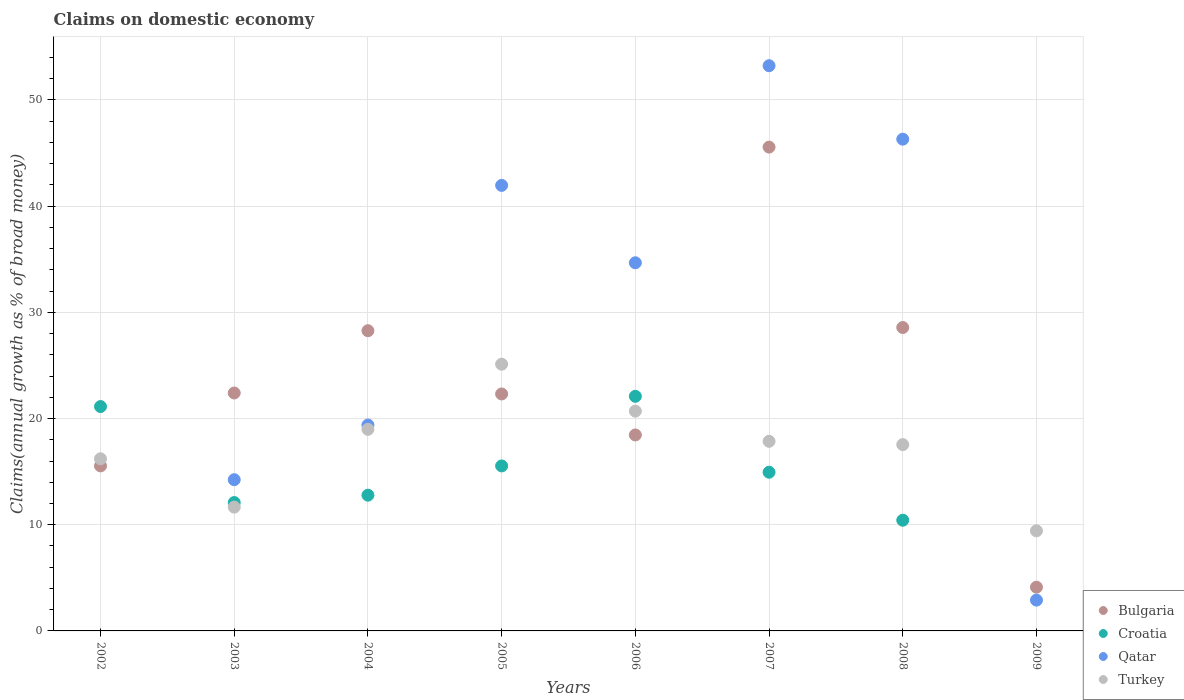How many different coloured dotlines are there?
Keep it short and to the point. 4. What is the percentage of broad money claimed on domestic economy in Bulgaria in 2005?
Your answer should be compact. 22.32. Across all years, what is the maximum percentage of broad money claimed on domestic economy in Bulgaria?
Give a very brief answer. 45.56. Across all years, what is the minimum percentage of broad money claimed on domestic economy in Bulgaria?
Make the answer very short. 4.12. In which year was the percentage of broad money claimed on domestic economy in Bulgaria maximum?
Ensure brevity in your answer.  2007. What is the total percentage of broad money claimed on domestic economy in Qatar in the graph?
Keep it short and to the point. 212.69. What is the difference between the percentage of broad money claimed on domestic economy in Turkey in 2003 and that in 2007?
Keep it short and to the point. -6.2. What is the difference between the percentage of broad money claimed on domestic economy in Croatia in 2005 and the percentage of broad money claimed on domestic economy in Turkey in 2007?
Ensure brevity in your answer.  -2.32. What is the average percentage of broad money claimed on domestic economy in Bulgaria per year?
Provide a succinct answer. 23.15. In the year 2009, what is the difference between the percentage of broad money claimed on domestic economy in Turkey and percentage of broad money claimed on domestic economy in Bulgaria?
Provide a short and direct response. 5.31. In how many years, is the percentage of broad money claimed on domestic economy in Turkey greater than 2 %?
Provide a succinct answer. 8. What is the ratio of the percentage of broad money claimed on domestic economy in Qatar in 2006 to that in 2007?
Keep it short and to the point. 0.65. Is the difference between the percentage of broad money claimed on domestic economy in Turkey in 2005 and 2006 greater than the difference between the percentage of broad money claimed on domestic economy in Bulgaria in 2005 and 2006?
Your response must be concise. Yes. What is the difference between the highest and the second highest percentage of broad money claimed on domestic economy in Qatar?
Ensure brevity in your answer.  6.92. What is the difference between the highest and the lowest percentage of broad money claimed on domestic economy in Turkey?
Keep it short and to the point. 15.69. Is it the case that in every year, the sum of the percentage of broad money claimed on domestic economy in Croatia and percentage of broad money claimed on domestic economy in Bulgaria  is greater than the percentage of broad money claimed on domestic economy in Qatar?
Give a very brief answer. No. Does the percentage of broad money claimed on domestic economy in Bulgaria monotonically increase over the years?
Offer a very short reply. No. How many dotlines are there?
Ensure brevity in your answer.  4. How many years are there in the graph?
Offer a terse response. 8. Does the graph contain any zero values?
Provide a succinct answer. Yes. Does the graph contain grids?
Make the answer very short. Yes. How are the legend labels stacked?
Offer a very short reply. Vertical. What is the title of the graph?
Provide a succinct answer. Claims on domestic economy. Does "Georgia" appear as one of the legend labels in the graph?
Your response must be concise. No. What is the label or title of the Y-axis?
Provide a short and direct response. Claims(annual growth as % of broad money). What is the Claims(annual growth as % of broad money) in Bulgaria in 2002?
Make the answer very short. 15.54. What is the Claims(annual growth as % of broad money) in Croatia in 2002?
Give a very brief answer. 21.13. What is the Claims(annual growth as % of broad money) in Qatar in 2002?
Keep it short and to the point. 0. What is the Claims(annual growth as % of broad money) in Turkey in 2002?
Keep it short and to the point. 16.21. What is the Claims(annual growth as % of broad money) in Bulgaria in 2003?
Offer a very short reply. 22.41. What is the Claims(annual growth as % of broad money) of Croatia in 2003?
Give a very brief answer. 12.09. What is the Claims(annual growth as % of broad money) of Qatar in 2003?
Provide a short and direct response. 14.24. What is the Claims(annual growth as % of broad money) in Turkey in 2003?
Your answer should be compact. 11.66. What is the Claims(annual growth as % of broad money) of Bulgaria in 2004?
Ensure brevity in your answer.  28.27. What is the Claims(annual growth as % of broad money) of Croatia in 2004?
Your response must be concise. 12.78. What is the Claims(annual growth as % of broad money) in Qatar in 2004?
Ensure brevity in your answer.  19.39. What is the Claims(annual growth as % of broad money) of Turkey in 2004?
Ensure brevity in your answer.  18.98. What is the Claims(annual growth as % of broad money) in Bulgaria in 2005?
Provide a succinct answer. 22.32. What is the Claims(annual growth as % of broad money) of Croatia in 2005?
Your answer should be compact. 15.54. What is the Claims(annual growth as % of broad money) in Qatar in 2005?
Provide a succinct answer. 41.96. What is the Claims(annual growth as % of broad money) of Turkey in 2005?
Your response must be concise. 25.12. What is the Claims(annual growth as % of broad money) of Bulgaria in 2006?
Your answer should be compact. 18.45. What is the Claims(annual growth as % of broad money) in Croatia in 2006?
Provide a succinct answer. 22.09. What is the Claims(annual growth as % of broad money) of Qatar in 2006?
Your answer should be very brief. 34.67. What is the Claims(annual growth as % of broad money) of Turkey in 2006?
Offer a very short reply. 20.7. What is the Claims(annual growth as % of broad money) in Bulgaria in 2007?
Ensure brevity in your answer.  45.56. What is the Claims(annual growth as % of broad money) of Croatia in 2007?
Give a very brief answer. 14.94. What is the Claims(annual growth as % of broad money) of Qatar in 2007?
Make the answer very short. 53.22. What is the Claims(annual growth as % of broad money) in Turkey in 2007?
Provide a short and direct response. 17.86. What is the Claims(annual growth as % of broad money) of Bulgaria in 2008?
Offer a terse response. 28.57. What is the Claims(annual growth as % of broad money) of Croatia in 2008?
Offer a very short reply. 10.42. What is the Claims(annual growth as % of broad money) of Qatar in 2008?
Give a very brief answer. 46.31. What is the Claims(annual growth as % of broad money) in Turkey in 2008?
Your answer should be very brief. 17.54. What is the Claims(annual growth as % of broad money) in Bulgaria in 2009?
Ensure brevity in your answer.  4.12. What is the Claims(annual growth as % of broad money) of Qatar in 2009?
Your answer should be compact. 2.9. What is the Claims(annual growth as % of broad money) of Turkey in 2009?
Give a very brief answer. 9.43. Across all years, what is the maximum Claims(annual growth as % of broad money) in Bulgaria?
Provide a succinct answer. 45.56. Across all years, what is the maximum Claims(annual growth as % of broad money) of Croatia?
Make the answer very short. 22.09. Across all years, what is the maximum Claims(annual growth as % of broad money) in Qatar?
Make the answer very short. 53.22. Across all years, what is the maximum Claims(annual growth as % of broad money) of Turkey?
Ensure brevity in your answer.  25.12. Across all years, what is the minimum Claims(annual growth as % of broad money) in Bulgaria?
Your response must be concise. 4.12. Across all years, what is the minimum Claims(annual growth as % of broad money) of Croatia?
Keep it short and to the point. 0. Across all years, what is the minimum Claims(annual growth as % of broad money) in Turkey?
Provide a succinct answer. 9.43. What is the total Claims(annual growth as % of broad money) of Bulgaria in the graph?
Offer a terse response. 185.24. What is the total Claims(annual growth as % of broad money) in Croatia in the graph?
Your answer should be very brief. 109. What is the total Claims(annual growth as % of broad money) of Qatar in the graph?
Keep it short and to the point. 212.69. What is the total Claims(annual growth as % of broad money) of Turkey in the graph?
Your response must be concise. 137.49. What is the difference between the Claims(annual growth as % of broad money) of Bulgaria in 2002 and that in 2003?
Provide a succinct answer. -6.86. What is the difference between the Claims(annual growth as % of broad money) in Croatia in 2002 and that in 2003?
Offer a very short reply. 9.04. What is the difference between the Claims(annual growth as % of broad money) of Turkey in 2002 and that in 2003?
Offer a terse response. 4.55. What is the difference between the Claims(annual growth as % of broad money) of Bulgaria in 2002 and that in 2004?
Your response must be concise. -12.73. What is the difference between the Claims(annual growth as % of broad money) in Croatia in 2002 and that in 2004?
Ensure brevity in your answer.  8.35. What is the difference between the Claims(annual growth as % of broad money) of Turkey in 2002 and that in 2004?
Offer a terse response. -2.77. What is the difference between the Claims(annual growth as % of broad money) in Bulgaria in 2002 and that in 2005?
Provide a short and direct response. -6.77. What is the difference between the Claims(annual growth as % of broad money) in Croatia in 2002 and that in 2005?
Keep it short and to the point. 5.59. What is the difference between the Claims(annual growth as % of broad money) of Turkey in 2002 and that in 2005?
Give a very brief answer. -8.91. What is the difference between the Claims(annual growth as % of broad money) of Bulgaria in 2002 and that in 2006?
Keep it short and to the point. -2.91. What is the difference between the Claims(annual growth as % of broad money) of Croatia in 2002 and that in 2006?
Offer a terse response. -0.96. What is the difference between the Claims(annual growth as % of broad money) in Turkey in 2002 and that in 2006?
Provide a succinct answer. -4.49. What is the difference between the Claims(annual growth as % of broad money) in Bulgaria in 2002 and that in 2007?
Give a very brief answer. -30.02. What is the difference between the Claims(annual growth as % of broad money) of Croatia in 2002 and that in 2007?
Offer a very short reply. 6.18. What is the difference between the Claims(annual growth as % of broad money) in Turkey in 2002 and that in 2007?
Your answer should be very brief. -1.65. What is the difference between the Claims(annual growth as % of broad money) in Bulgaria in 2002 and that in 2008?
Your answer should be very brief. -13.03. What is the difference between the Claims(annual growth as % of broad money) in Croatia in 2002 and that in 2008?
Offer a very short reply. 10.7. What is the difference between the Claims(annual growth as % of broad money) in Turkey in 2002 and that in 2008?
Your answer should be very brief. -1.34. What is the difference between the Claims(annual growth as % of broad money) of Bulgaria in 2002 and that in 2009?
Provide a short and direct response. 11.42. What is the difference between the Claims(annual growth as % of broad money) in Turkey in 2002 and that in 2009?
Ensure brevity in your answer.  6.78. What is the difference between the Claims(annual growth as % of broad money) in Bulgaria in 2003 and that in 2004?
Offer a very short reply. -5.87. What is the difference between the Claims(annual growth as % of broad money) of Croatia in 2003 and that in 2004?
Offer a terse response. -0.7. What is the difference between the Claims(annual growth as % of broad money) in Qatar in 2003 and that in 2004?
Make the answer very short. -5.15. What is the difference between the Claims(annual growth as % of broad money) in Turkey in 2003 and that in 2004?
Give a very brief answer. -7.32. What is the difference between the Claims(annual growth as % of broad money) of Bulgaria in 2003 and that in 2005?
Provide a short and direct response. 0.09. What is the difference between the Claims(annual growth as % of broad money) in Croatia in 2003 and that in 2005?
Ensure brevity in your answer.  -3.45. What is the difference between the Claims(annual growth as % of broad money) of Qatar in 2003 and that in 2005?
Offer a very short reply. -27.72. What is the difference between the Claims(annual growth as % of broad money) in Turkey in 2003 and that in 2005?
Make the answer very short. -13.46. What is the difference between the Claims(annual growth as % of broad money) in Bulgaria in 2003 and that in 2006?
Provide a succinct answer. 3.95. What is the difference between the Claims(annual growth as % of broad money) of Croatia in 2003 and that in 2006?
Ensure brevity in your answer.  -10.01. What is the difference between the Claims(annual growth as % of broad money) in Qatar in 2003 and that in 2006?
Make the answer very short. -20.43. What is the difference between the Claims(annual growth as % of broad money) of Turkey in 2003 and that in 2006?
Offer a very short reply. -9.04. What is the difference between the Claims(annual growth as % of broad money) in Bulgaria in 2003 and that in 2007?
Your answer should be compact. -23.15. What is the difference between the Claims(annual growth as % of broad money) in Croatia in 2003 and that in 2007?
Your response must be concise. -2.86. What is the difference between the Claims(annual growth as % of broad money) of Qatar in 2003 and that in 2007?
Your response must be concise. -38.98. What is the difference between the Claims(annual growth as % of broad money) of Turkey in 2003 and that in 2007?
Provide a short and direct response. -6.2. What is the difference between the Claims(annual growth as % of broad money) in Bulgaria in 2003 and that in 2008?
Offer a terse response. -6.16. What is the difference between the Claims(annual growth as % of broad money) of Croatia in 2003 and that in 2008?
Your response must be concise. 1.66. What is the difference between the Claims(annual growth as % of broad money) in Qatar in 2003 and that in 2008?
Provide a succinct answer. -32.07. What is the difference between the Claims(annual growth as % of broad money) of Turkey in 2003 and that in 2008?
Offer a terse response. -5.88. What is the difference between the Claims(annual growth as % of broad money) of Bulgaria in 2003 and that in 2009?
Ensure brevity in your answer.  18.29. What is the difference between the Claims(annual growth as % of broad money) in Qatar in 2003 and that in 2009?
Your answer should be very brief. 11.34. What is the difference between the Claims(annual growth as % of broad money) in Turkey in 2003 and that in 2009?
Offer a terse response. 2.23. What is the difference between the Claims(annual growth as % of broad money) in Bulgaria in 2004 and that in 2005?
Your answer should be compact. 5.96. What is the difference between the Claims(annual growth as % of broad money) in Croatia in 2004 and that in 2005?
Provide a short and direct response. -2.75. What is the difference between the Claims(annual growth as % of broad money) in Qatar in 2004 and that in 2005?
Offer a very short reply. -22.57. What is the difference between the Claims(annual growth as % of broad money) in Turkey in 2004 and that in 2005?
Your response must be concise. -6.14. What is the difference between the Claims(annual growth as % of broad money) of Bulgaria in 2004 and that in 2006?
Offer a very short reply. 9.82. What is the difference between the Claims(annual growth as % of broad money) of Croatia in 2004 and that in 2006?
Ensure brevity in your answer.  -9.31. What is the difference between the Claims(annual growth as % of broad money) in Qatar in 2004 and that in 2006?
Your answer should be compact. -15.28. What is the difference between the Claims(annual growth as % of broad money) of Turkey in 2004 and that in 2006?
Your answer should be very brief. -1.71. What is the difference between the Claims(annual growth as % of broad money) of Bulgaria in 2004 and that in 2007?
Provide a short and direct response. -17.29. What is the difference between the Claims(annual growth as % of broad money) in Croatia in 2004 and that in 2007?
Your answer should be very brief. -2.16. What is the difference between the Claims(annual growth as % of broad money) of Qatar in 2004 and that in 2007?
Your response must be concise. -33.84. What is the difference between the Claims(annual growth as % of broad money) in Turkey in 2004 and that in 2007?
Ensure brevity in your answer.  1.13. What is the difference between the Claims(annual growth as % of broad money) in Bulgaria in 2004 and that in 2008?
Make the answer very short. -0.3. What is the difference between the Claims(annual growth as % of broad money) in Croatia in 2004 and that in 2008?
Provide a short and direct response. 2.36. What is the difference between the Claims(annual growth as % of broad money) in Qatar in 2004 and that in 2008?
Make the answer very short. -26.92. What is the difference between the Claims(annual growth as % of broad money) of Turkey in 2004 and that in 2008?
Your answer should be very brief. 1.44. What is the difference between the Claims(annual growth as % of broad money) of Bulgaria in 2004 and that in 2009?
Give a very brief answer. 24.15. What is the difference between the Claims(annual growth as % of broad money) of Qatar in 2004 and that in 2009?
Provide a succinct answer. 16.49. What is the difference between the Claims(annual growth as % of broad money) of Turkey in 2004 and that in 2009?
Provide a short and direct response. 9.56. What is the difference between the Claims(annual growth as % of broad money) in Bulgaria in 2005 and that in 2006?
Your answer should be compact. 3.86. What is the difference between the Claims(annual growth as % of broad money) of Croatia in 2005 and that in 2006?
Ensure brevity in your answer.  -6.55. What is the difference between the Claims(annual growth as % of broad money) of Qatar in 2005 and that in 2006?
Give a very brief answer. 7.29. What is the difference between the Claims(annual growth as % of broad money) in Turkey in 2005 and that in 2006?
Your answer should be compact. 4.42. What is the difference between the Claims(annual growth as % of broad money) of Bulgaria in 2005 and that in 2007?
Provide a short and direct response. -23.24. What is the difference between the Claims(annual growth as % of broad money) of Croatia in 2005 and that in 2007?
Give a very brief answer. 0.59. What is the difference between the Claims(annual growth as % of broad money) in Qatar in 2005 and that in 2007?
Keep it short and to the point. -11.27. What is the difference between the Claims(annual growth as % of broad money) in Turkey in 2005 and that in 2007?
Provide a short and direct response. 7.26. What is the difference between the Claims(annual growth as % of broad money) of Bulgaria in 2005 and that in 2008?
Offer a very short reply. -6.26. What is the difference between the Claims(annual growth as % of broad money) in Croatia in 2005 and that in 2008?
Offer a terse response. 5.11. What is the difference between the Claims(annual growth as % of broad money) in Qatar in 2005 and that in 2008?
Offer a very short reply. -4.35. What is the difference between the Claims(annual growth as % of broad money) in Turkey in 2005 and that in 2008?
Provide a succinct answer. 7.57. What is the difference between the Claims(annual growth as % of broad money) of Bulgaria in 2005 and that in 2009?
Ensure brevity in your answer.  18.2. What is the difference between the Claims(annual growth as % of broad money) in Qatar in 2005 and that in 2009?
Keep it short and to the point. 39.06. What is the difference between the Claims(annual growth as % of broad money) of Turkey in 2005 and that in 2009?
Your answer should be very brief. 15.69. What is the difference between the Claims(annual growth as % of broad money) of Bulgaria in 2006 and that in 2007?
Offer a very short reply. -27.11. What is the difference between the Claims(annual growth as % of broad money) of Croatia in 2006 and that in 2007?
Your answer should be very brief. 7.15. What is the difference between the Claims(annual growth as % of broad money) in Qatar in 2006 and that in 2007?
Ensure brevity in your answer.  -18.56. What is the difference between the Claims(annual growth as % of broad money) in Turkey in 2006 and that in 2007?
Offer a terse response. 2.84. What is the difference between the Claims(annual growth as % of broad money) of Bulgaria in 2006 and that in 2008?
Offer a terse response. -10.12. What is the difference between the Claims(annual growth as % of broad money) in Croatia in 2006 and that in 2008?
Your answer should be very brief. 11.67. What is the difference between the Claims(annual growth as % of broad money) in Qatar in 2006 and that in 2008?
Your answer should be compact. -11.64. What is the difference between the Claims(annual growth as % of broad money) of Turkey in 2006 and that in 2008?
Your answer should be compact. 3.15. What is the difference between the Claims(annual growth as % of broad money) of Bulgaria in 2006 and that in 2009?
Offer a very short reply. 14.33. What is the difference between the Claims(annual growth as % of broad money) of Qatar in 2006 and that in 2009?
Offer a very short reply. 31.77. What is the difference between the Claims(annual growth as % of broad money) in Turkey in 2006 and that in 2009?
Offer a very short reply. 11.27. What is the difference between the Claims(annual growth as % of broad money) in Bulgaria in 2007 and that in 2008?
Your response must be concise. 16.99. What is the difference between the Claims(annual growth as % of broad money) of Croatia in 2007 and that in 2008?
Provide a succinct answer. 4.52. What is the difference between the Claims(annual growth as % of broad money) in Qatar in 2007 and that in 2008?
Offer a terse response. 6.92. What is the difference between the Claims(annual growth as % of broad money) in Turkey in 2007 and that in 2008?
Keep it short and to the point. 0.31. What is the difference between the Claims(annual growth as % of broad money) in Bulgaria in 2007 and that in 2009?
Provide a succinct answer. 41.44. What is the difference between the Claims(annual growth as % of broad money) in Qatar in 2007 and that in 2009?
Ensure brevity in your answer.  50.32. What is the difference between the Claims(annual growth as % of broad money) of Turkey in 2007 and that in 2009?
Your response must be concise. 8.43. What is the difference between the Claims(annual growth as % of broad money) of Bulgaria in 2008 and that in 2009?
Ensure brevity in your answer.  24.45. What is the difference between the Claims(annual growth as % of broad money) in Qatar in 2008 and that in 2009?
Give a very brief answer. 43.41. What is the difference between the Claims(annual growth as % of broad money) in Turkey in 2008 and that in 2009?
Your answer should be compact. 8.12. What is the difference between the Claims(annual growth as % of broad money) in Bulgaria in 2002 and the Claims(annual growth as % of broad money) in Croatia in 2003?
Provide a short and direct response. 3.45. What is the difference between the Claims(annual growth as % of broad money) in Bulgaria in 2002 and the Claims(annual growth as % of broad money) in Qatar in 2003?
Your answer should be very brief. 1.3. What is the difference between the Claims(annual growth as % of broad money) of Bulgaria in 2002 and the Claims(annual growth as % of broad money) of Turkey in 2003?
Your answer should be very brief. 3.88. What is the difference between the Claims(annual growth as % of broad money) in Croatia in 2002 and the Claims(annual growth as % of broad money) in Qatar in 2003?
Provide a short and direct response. 6.89. What is the difference between the Claims(annual growth as % of broad money) of Croatia in 2002 and the Claims(annual growth as % of broad money) of Turkey in 2003?
Offer a terse response. 9.47. What is the difference between the Claims(annual growth as % of broad money) of Bulgaria in 2002 and the Claims(annual growth as % of broad money) of Croatia in 2004?
Ensure brevity in your answer.  2.76. What is the difference between the Claims(annual growth as % of broad money) of Bulgaria in 2002 and the Claims(annual growth as % of broad money) of Qatar in 2004?
Your answer should be compact. -3.85. What is the difference between the Claims(annual growth as % of broad money) in Bulgaria in 2002 and the Claims(annual growth as % of broad money) in Turkey in 2004?
Provide a succinct answer. -3.44. What is the difference between the Claims(annual growth as % of broad money) in Croatia in 2002 and the Claims(annual growth as % of broad money) in Qatar in 2004?
Provide a succinct answer. 1.74. What is the difference between the Claims(annual growth as % of broad money) of Croatia in 2002 and the Claims(annual growth as % of broad money) of Turkey in 2004?
Keep it short and to the point. 2.15. What is the difference between the Claims(annual growth as % of broad money) of Bulgaria in 2002 and the Claims(annual growth as % of broad money) of Croatia in 2005?
Your answer should be compact. 0. What is the difference between the Claims(annual growth as % of broad money) in Bulgaria in 2002 and the Claims(annual growth as % of broad money) in Qatar in 2005?
Ensure brevity in your answer.  -26.41. What is the difference between the Claims(annual growth as % of broad money) in Bulgaria in 2002 and the Claims(annual growth as % of broad money) in Turkey in 2005?
Your answer should be compact. -9.58. What is the difference between the Claims(annual growth as % of broad money) of Croatia in 2002 and the Claims(annual growth as % of broad money) of Qatar in 2005?
Provide a succinct answer. -20.83. What is the difference between the Claims(annual growth as % of broad money) of Croatia in 2002 and the Claims(annual growth as % of broad money) of Turkey in 2005?
Provide a succinct answer. -3.99. What is the difference between the Claims(annual growth as % of broad money) in Bulgaria in 2002 and the Claims(annual growth as % of broad money) in Croatia in 2006?
Your answer should be compact. -6.55. What is the difference between the Claims(annual growth as % of broad money) of Bulgaria in 2002 and the Claims(annual growth as % of broad money) of Qatar in 2006?
Your answer should be compact. -19.13. What is the difference between the Claims(annual growth as % of broad money) in Bulgaria in 2002 and the Claims(annual growth as % of broad money) in Turkey in 2006?
Make the answer very short. -5.15. What is the difference between the Claims(annual growth as % of broad money) of Croatia in 2002 and the Claims(annual growth as % of broad money) of Qatar in 2006?
Your answer should be very brief. -13.54. What is the difference between the Claims(annual growth as % of broad money) in Croatia in 2002 and the Claims(annual growth as % of broad money) in Turkey in 2006?
Offer a terse response. 0.43. What is the difference between the Claims(annual growth as % of broad money) in Bulgaria in 2002 and the Claims(annual growth as % of broad money) in Croatia in 2007?
Your answer should be very brief. 0.6. What is the difference between the Claims(annual growth as % of broad money) in Bulgaria in 2002 and the Claims(annual growth as % of broad money) in Qatar in 2007?
Keep it short and to the point. -37.68. What is the difference between the Claims(annual growth as % of broad money) in Bulgaria in 2002 and the Claims(annual growth as % of broad money) in Turkey in 2007?
Make the answer very short. -2.31. What is the difference between the Claims(annual growth as % of broad money) of Croatia in 2002 and the Claims(annual growth as % of broad money) of Qatar in 2007?
Make the answer very short. -32.1. What is the difference between the Claims(annual growth as % of broad money) of Croatia in 2002 and the Claims(annual growth as % of broad money) of Turkey in 2007?
Make the answer very short. 3.27. What is the difference between the Claims(annual growth as % of broad money) in Bulgaria in 2002 and the Claims(annual growth as % of broad money) in Croatia in 2008?
Make the answer very short. 5.12. What is the difference between the Claims(annual growth as % of broad money) in Bulgaria in 2002 and the Claims(annual growth as % of broad money) in Qatar in 2008?
Give a very brief answer. -30.77. What is the difference between the Claims(annual growth as % of broad money) of Bulgaria in 2002 and the Claims(annual growth as % of broad money) of Turkey in 2008?
Keep it short and to the point. -2. What is the difference between the Claims(annual growth as % of broad money) of Croatia in 2002 and the Claims(annual growth as % of broad money) of Qatar in 2008?
Offer a terse response. -25.18. What is the difference between the Claims(annual growth as % of broad money) in Croatia in 2002 and the Claims(annual growth as % of broad money) in Turkey in 2008?
Give a very brief answer. 3.58. What is the difference between the Claims(annual growth as % of broad money) of Bulgaria in 2002 and the Claims(annual growth as % of broad money) of Qatar in 2009?
Offer a very short reply. 12.64. What is the difference between the Claims(annual growth as % of broad money) of Bulgaria in 2002 and the Claims(annual growth as % of broad money) of Turkey in 2009?
Offer a terse response. 6.11. What is the difference between the Claims(annual growth as % of broad money) in Croatia in 2002 and the Claims(annual growth as % of broad money) in Qatar in 2009?
Ensure brevity in your answer.  18.23. What is the difference between the Claims(annual growth as % of broad money) of Croatia in 2002 and the Claims(annual growth as % of broad money) of Turkey in 2009?
Keep it short and to the point. 11.7. What is the difference between the Claims(annual growth as % of broad money) in Bulgaria in 2003 and the Claims(annual growth as % of broad money) in Croatia in 2004?
Provide a short and direct response. 9.62. What is the difference between the Claims(annual growth as % of broad money) in Bulgaria in 2003 and the Claims(annual growth as % of broad money) in Qatar in 2004?
Give a very brief answer. 3.02. What is the difference between the Claims(annual growth as % of broad money) of Bulgaria in 2003 and the Claims(annual growth as % of broad money) of Turkey in 2004?
Give a very brief answer. 3.42. What is the difference between the Claims(annual growth as % of broad money) in Croatia in 2003 and the Claims(annual growth as % of broad money) in Qatar in 2004?
Your response must be concise. -7.3. What is the difference between the Claims(annual growth as % of broad money) of Croatia in 2003 and the Claims(annual growth as % of broad money) of Turkey in 2004?
Offer a very short reply. -6.9. What is the difference between the Claims(annual growth as % of broad money) of Qatar in 2003 and the Claims(annual growth as % of broad money) of Turkey in 2004?
Provide a succinct answer. -4.74. What is the difference between the Claims(annual growth as % of broad money) of Bulgaria in 2003 and the Claims(annual growth as % of broad money) of Croatia in 2005?
Your answer should be very brief. 6.87. What is the difference between the Claims(annual growth as % of broad money) in Bulgaria in 2003 and the Claims(annual growth as % of broad money) in Qatar in 2005?
Ensure brevity in your answer.  -19.55. What is the difference between the Claims(annual growth as % of broad money) of Bulgaria in 2003 and the Claims(annual growth as % of broad money) of Turkey in 2005?
Your response must be concise. -2.71. What is the difference between the Claims(annual growth as % of broad money) in Croatia in 2003 and the Claims(annual growth as % of broad money) in Qatar in 2005?
Your answer should be compact. -29.87. What is the difference between the Claims(annual growth as % of broad money) of Croatia in 2003 and the Claims(annual growth as % of broad money) of Turkey in 2005?
Your answer should be compact. -13.03. What is the difference between the Claims(annual growth as % of broad money) of Qatar in 2003 and the Claims(annual growth as % of broad money) of Turkey in 2005?
Keep it short and to the point. -10.88. What is the difference between the Claims(annual growth as % of broad money) in Bulgaria in 2003 and the Claims(annual growth as % of broad money) in Croatia in 2006?
Provide a short and direct response. 0.31. What is the difference between the Claims(annual growth as % of broad money) in Bulgaria in 2003 and the Claims(annual growth as % of broad money) in Qatar in 2006?
Provide a succinct answer. -12.26. What is the difference between the Claims(annual growth as % of broad money) in Bulgaria in 2003 and the Claims(annual growth as % of broad money) in Turkey in 2006?
Make the answer very short. 1.71. What is the difference between the Claims(annual growth as % of broad money) of Croatia in 2003 and the Claims(annual growth as % of broad money) of Qatar in 2006?
Give a very brief answer. -22.58. What is the difference between the Claims(annual growth as % of broad money) in Croatia in 2003 and the Claims(annual growth as % of broad money) in Turkey in 2006?
Your answer should be compact. -8.61. What is the difference between the Claims(annual growth as % of broad money) in Qatar in 2003 and the Claims(annual growth as % of broad money) in Turkey in 2006?
Make the answer very short. -6.46. What is the difference between the Claims(annual growth as % of broad money) in Bulgaria in 2003 and the Claims(annual growth as % of broad money) in Croatia in 2007?
Your response must be concise. 7.46. What is the difference between the Claims(annual growth as % of broad money) in Bulgaria in 2003 and the Claims(annual growth as % of broad money) in Qatar in 2007?
Your response must be concise. -30.82. What is the difference between the Claims(annual growth as % of broad money) in Bulgaria in 2003 and the Claims(annual growth as % of broad money) in Turkey in 2007?
Keep it short and to the point. 4.55. What is the difference between the Claims(annual growth as % of broad money) in Croatia in 2003 and the Claims(annual growth as % of broad money) in Qatar in 2007?
Give a very brief answer. -41.14. What is the difference between the Claims(annual growth as % of broad money) of Croatia in 2003 and the Claims(annual growth as % of broad money) of Turkey in 2007?
Provide a succinct answer. -5.77. What is the difference between the Claims(annual growth as % of broad money) in Qatar in 2003 and the Claims(annual growth as % of broad money) in Turkey in 2007?
Give a very brief answer. -3.62. What is the difference between the Claims(annual growth as % of broad money) in Bulgaria in 2003 and the Claims(annual growth as % of broad money) in Croatia in 2008?
Provide a short and direct response. 11.98. What is the difference between the Claims(annual growth as % of broad money) of Bulgaria in 2003 and the Claims(annual growth as % of broad money) of Qatar in 2008?
Ensure brevity in your answer.  -23.9. What is the difference between the Claims(annual growth as % of broad money) in Bulgaria in 2003 and the Claims(annual growth as % of broad money) in Turkey in 2008?
Provide a succinct answer. 4.86. What is the difference between the Claims(annual growth as % of broad money) of Croatia in 2003 and the Claims(annual growth as % of broad money) of Qatar in 2008?
Your answer should be very brief. -34.22. What is the difference between the Claims(annual growth as % of broad money) of Croatia in 2003 and the Claims(annual growth as % of broad money) of Turkey in 2008?
Make the answer very short. -5.46. What is the difference between the Claims(annual growth as % of broad money) in Qatar in 2003 and the Claims(annual growth as % of broad money) in Turkey in 2008?
Your response must be concise. -3.3. What is the difference between the Claims(annual growth as % of broad money) in Bulgaria in 2003 and the Claims(annual growth as % of broad money) in Qatar in 2009?
Make the answer very short. 19.51. What is the difference between the Claims(annual growth as % of broad money) of Bulgaria in 2003 and the Claims(annual growth as % of broad money) of Turkey in 2009?
Keep it short and to the point. 12.98. What is the difference between the Claims(annual growth as % of broad money) in Croatia in 2003 and the Claims(annual growth as % of broad money) in Qatar in 2009?
Your answer should be compact. 9.19. What is the difference between the Claims(annual growth as % of broad money) in Croatia in 2003 and the Claims(annual growth as % of broad money) in Turkey in 2009?
Your response must be concise. 2.66. What is the difference between the Claims(annual growth as % of broad money) of Qatar in 2003 and the Claims(annual growth as % of broad money) of Turkey in 2009?
Make the answer very short. 4.81. What is the difference between the Claims(annual growth as % of broad money) in Bulgaria in 2004 and the Claims(annual growth as % of broad money) in Croatia in 2005?
Make the answer very short. 12.73. What is the difference between the Claims(annual growth as % of broad money) in Bulgaria in 2004 and the Claims(annual growth as % of broad money) in Qatar in 2005?
Your answer should be very brief. -13.69. What is the difference between the Claims(annual growth as % of broad money) of Bulgaria in 2004 and the Claims(annual growth as % of broad money) of Turkey in 2005?
Provide a short and direct response. 3.15. What is the difference between the Claims(annual growth as % of broad money) of Croatia in 2004 and the Claims(annual growth as % of broad money) of Qatar in 2005?
Keep it short and to the point. -29.17. What is the difference between the Claims(annual growth as % of broad money) in Croatia in 2004 and the Claims(annual growth as % of broad money) in Turkey in 2005?
Offer a very short reply. -12.33. What is the difference between the Claims(annual growth as % of broad money) of Qatar in 2004 and the Claims(annual growth as % of broad money) of Turkey in 2005?
Give a very brief answer. -5.73. What is the difference between the Claims(annual growth as % of broad money) in Bulgaria in 2004 and the Claims(annual growth as % of broad money) in Croatia in 2006?
Offer a very short reply. 6.18. What is the difference between the Claims(annual growth as % of broad money) of Bulgaria in 2004 and the Claims(annual growth as % of broad money) of Qatar in 2006?
Make the answer very short. -6.4. What is the difference between the Claims(annual growth as % of broad money) of Bulgaria in 2004 and the Claims(annual growth as % of broad money) of Turkey in 2006?
Your response must be concise. 7.57. What is the difference between the Claims(annual growth as % of broad money) in Croatia in 2004 and the Claims(annual growth as % of broad money) in Qatar in 2006?
Offer a terse response. -21.88. What is the difference between the Claims(annual growth as % of broad money) in Croatia in 2004 and the Claims(annual growth as % of broad money) in Turkey in 2006?
Provide a short and direct response. -7.91. What is the difference between the Claims(annual growth as % of broad money) in Qatar in 2004 and the Claims(annual growth as % of broad money) in Turkey in 2006?
Your response must be concise. -1.31. What is the difference between the Claims(annual growth as % of broad money) of Bulgaria in 2004 and the Claims(annual growth as % of broad money) of Croatia in 2007?
Your answer should be very brief. 13.33. What is the difference between the Claims(annual growth as % of broad money) of Bulgaria in 2004 and the Claims(annual growth as % of broad money) of Qatar in 2007?
Keep it short and to the point. -24.95. What is the difference between the Claims(annual growth as % of broad money) of Bulgaria in 2004 and the Claims(annual growth as % of broad money) of Turkey in 2007?
Provide a succinct answer. 10.41. What is the difference between the Claims(annual growth as % of broad money) in Croatia in 2004 and the Claims(annual growth as % of broad money) in Qatar in 2007?
Ensure brevity in your answer.  -40.44. What is the difference between the Claims(annual growth as % of broad money) in Croatia in 2004 and the Claims(annual growth as % of broad money) in Turkey in 2007?
Offer a very short reply. -5.07. What is the difference between the Claims(annual growth as % of broad money) in Qatar in 2004 and the Claims(annual growth as % of broad money) in Turkey in 2007?
Ensure brevity in your answer.  1.53. What is the difference between the Claims(annual growth as % of broad money) in Bulgaria in 2004 and the Claims(annual growth as % of broad money) in Croatia in 2008?
Offer a terse response. 17.85. What is the difference between the Claims(annual growth as % of broad money) of Bulgaria in 2004 and the Claims(annual growth as % of broad money) of Qatar in 2008?
Keep it short and to the point. -18.04. What is the difference between the Claims(annual growth as % of broad money) in Bulgaria in 2004 and the Claims(annual growth as % of broad money) in Turkey in 2008?
Ensure brevity in your answer.  10.73. What is the difference between the Claims(annual growth as % of broad money) in Croatia in 2004 and the Claims(annual growth as % of broad money) in Qatar in 2008?
Your answer should be compact. -33.52. What is the difference between the Claims(annual growth as % of broad money) of Croatia in 2004 and the Claims(annual growth as % of broad money) of Turkey in 2008?
Your response must be concise. -4.76. What is the difference between the Claims(annual growth as % of broad money) of Qatar in 2004 and the Claims(annual growth as % of broad money) of Turkey in 2008?
Your answer should be very brief. 1.84. What is the difference between the Claims(annual growth as % of broad money) in Bulgaria in 2004 and the Claims(annual growth as % of broad money) in Qatar in 2009?
Offer a very short reply. 25.37. What is the difference between the Claims(annual growth as % of broad money) of Bulgaria in 2004 and the Claims(annual growth as % of broad money) of Turkey in 2009?
Offer a terse response. 18.84. What is the difference between the Claims(annual growth as % of broad money) in Croatia in 2004 and the Claims(annual growth as % of broad money) in Qatar in 2009?
Offer a terse response. 9.88. What is the difference between the Claims(annual growth as % of broad money) of Croatia in 2004 and the Claims(annual growth as % of broad money) of Turkey in 2009?
Ensure brevity in your answer.  3.36. What is the difference between the Claims(annual growth as % of broad money) of Qatar in 2004 and the Claims(annual growth as % of broad money) of Turkey in 2009?
Offer a very short reply. 9.96. What is the difference between the Claims(annual growth as % of broad money) in Bulgaria in 2005 and the Claims(annual growth as % of broad money) in Croatia in 2006?
Your answer should be compact. 0.22. What is the difference between the Claims(annual growth as % of broad money) of Bulgaria in 2005 and the Claims(annual growth as % of broad money) of Qatar in 2006?
Provide a succinct answer. -12.35. What is the difference between the Claims(annual growth as % of broad money) in Bulgaria in 2005 and the Claims(annual growth as % of broad money) in Turkey in 2006?
Offer a very short reply. 1.62. What is the difference between the Claims(annual growth as % of broad money) in Croatia in 2005 and the Claims(annual growth as % of broad money) in Qatar in 2006?
Make the answer very short. -19.13. What is the difference between the Claims(annual growth as % of broad money) in Croatia in 2005 and the Claims(annual growth as % of broad money) in Turkey in 2006?
Your answer should be very brief. -5.16. What is the difference between the Claims(annual growth as % of broad money) in Qatar in 2005 and the Claims(annual growth as % of broad money) in Turkey in 2006?
Make the answer very short. 21.26. What is the difference between the Claims(annual growth as % of broad money) of Bulgaria in 2005 and the Claims(annual growth as % of broad money) of Croatia in 2007?
Make the answer very short. 7.37. What is the difference between the Claims(annual growth as % of broad money) in Bulgaria in 2005 and the Claims(annual growth as % of broad money) in Qatar in 2007?
Your answer should be very brief. -30.91. What is the difference between the Claims(annual growth as % of broad money) in Bulgaria in 2005 and the Claims(annual growth as % of broad money) in Turkey in 2007?
Give a very brief answer. 4.46. What is the difference between the Claims(annual growth as % of broad money) of Croatia in 2005 and the Claims(annual growth as % of broad money) of Qatar in 2007?
Ensure brevity in your answer.  -37.69. What is the difference between the Claims(annual growth as % of broad money) of Croatia in 2005 and the Claims(annual growth as % of broad money) of Turkey in 2007?
Make the answer very short. -2.32. What is the difference between the Claims(annual growth as % of broad money) of Qatar in 2005 and the Claims(annual growth as % of broad money) of Turkey in 2007?
Offer a very short reply. 24.1. What is the difference between the Claims(annual growth as % of broad money) of Bulgaria in 2005 and the Claims(annual growth as % of broad money) of Croatia in 2008?
Keep it short and to the point. 11.89. What is the difference between the Claims(annual growth as % of broad money) in Bulgaria in 2005 and the Claims(annual growth as % of broad money) in Qatar in 2008?
Keep it short and to the point. -23.99. What is the difference between the Claims(annual growth as % of broad money) in Bulgaria in 2005 and the Claims(annual growth as % of broad money) in Turkey in 2008?
Offer a very short reply. 4.77. What is the difference between the Claims(annual growth as % of broad money) in Croatia in 2005 and the Claims(annual growth as % of broad money) in Qatar in 2008?
Your answer should be compact. -30.77. What is the difference between the Claims(annual growth as % of broad money) of Croatia in 2005 and the Claims(annual growth as % of broad money) of Turkey in 2008?
Give a very brief answer. -2.01. What is the difference between the Claims(annual growth as % of broad money) in Qatar in 2005 and the Claims(annual growth as % of broad money) in Turkey in 2008?
Offer a terse response. 24.41. What is the difference between the Claims(annual growth as % of broad money) in Bulgaria in 2005 and the Claims(annual growth as % of broad money) in Qatar in 2009?
Your answer should be compact. 19.41. What is the difference between the Claims(annual growth as % of broad money) of Bulgaria in 2005 and the Claims(annual growth as % of broad money) of Turkey in 2009?
Your answer should be very brief. 12.89. What is the difference between the Claims(annual growth as % of broad money) in Croatia in 2005 and the Claims(annual growth as % of broad money) in Qatar in 2009?
Provide a short and direct response. 12.64. What is the difference between the Claims(annual growth as % of broad money) of Croatia in 2005 and the Claims(annual growth as % of broad money) of Turkey in 2009?
Offer a very short reply. 6.11. What is the difference between the Claims(annual growth as % of broad money) of Qatar in 2005 and the Claims(annual growth as % of broad money) of Turkey in 2009?
Make the answer very short. 32.53. What is the difference between the Claims(annual growth as % of broad money) in Bulgaria in 2006 and the Claims(annual growth as % of broad money) in Croatia in 2007?
Your response must be concise. 3.51. What is the difference between the Claims(annual growth as % of broad money) of Bulgaria in 2006 and the Claims(annual growth as % of broad money) of Qatar in 2007?
Provide a short and direct response. -34.77. What is the difference between the Claims(annual growth as % of broad money) of Bulgaria in 2006 and the Claims(annual growth as % of broad money) of Turkey in 2007?
Offer a very short reply. 0.6. What is the difference between the Claims(annual growth as % of broad money) in Croatia in 2006 and the Claims(annual growth as % of broad money) in Qatar in 2007?
Your answer should be compact. -31.13. What is the difference between the Claims(annual growth as % of broad money) of Croatia in 2006 and the Claims(annual growth as % of broad money) of Turkey in 2007?
Offer a very short reply. 4.24. What is the difference between the Claims(annual growth as % of broad money) of Qatar in 2006 and the Claims(annual growth as % of broad money) of Turkey in 2007?
Make the answer very short. 16.81. What is the difference between the Claims(annual growth as % of broad money) in Bulgaria in 2006 and the Claims(annual growth as % of broad money) in Croatia in 2008?
Your response must be concise. 8.03. What is the difference between the Claims(annual growth as % of broad money) of Bulgaria in 2006 and the Claims(annual growth as % of broad money) of Qatar in 2008?
Ensure brevity in your answer.  -27.85. What is the difference between the Claims(annual growth as % of broad money) of Bulgaria in 2006 and the Claims(annual growth as % of broad money) of Turkey in 2008?
Your response must be concise. 0.91. What is the difference between the Claims(annual growth as % of broad money) in Croatia in 2006 and the Claims(annual growth as % of broad money) in Qatar in 2008?
Keep it short and to the point. -24.22. What is the difference between the Claims(annual growth as % of broad money) of Croatia in 2006 and the Claims(annual growth as % of broad money) of Turkey in 2008?
Offer a terse response. 4.55. What is the difference between the Claims(annual growth as % of broad money) of Qatar in 2006 and the Claims(annual growth as % of broad money) of Turkey in 2008?
Ensure brevity in your answer.  17.12. What is the difference between the Claims(annual growth as % of broad money) in Bulgaria in 2006 and the Claims(annual growth as % of broad money) in Qatar in 2009?
Your response must be concise. 15.55. What is the difference between the Claims(annual growth as % of broad money) of Bulgaria in 2006 and the Claims(annual growth as % of broad money) of Turkey in 2009?
Your answer should be very brief. 9.03. What is the difference between the Claims(annual growth as % of broad money) in Croatia in 2006 and the Claims(annual growth as % of broad money) in Qatar in 2009?
Your answer should be compact. 19.19. What is the difference between the Claims(annual growth as % of broad money) of Croatia in 2006 and the Claims(annual growth as % of broad money) of Turkey in 2009?
Your answer should be compact. 12.67. What is the difference between the Claims(annual growth as % of broad money) of Qatar in 2006 and the Claims(annual growth as % of broad money) of Turkey in 2009?
Your answer should be compact. 25.24. What is the difference between the Claims(annual growth as % of broad money) of Bulgaria in 2007 and the Claims(annual growth as % of broad money) of Croatia in 2008?
Ensure brevity in your answer.  35.14. What is the difference between the Claims(annual growth as % of broad money) of Bulgaria in 2007 and the Claims(annual growth as % of broad money) of Qatar in 2008?
Keep it short and to the point. -0.75. What is the difference between the Claims(annual growth as % of broad money) in Bulgaria in 2007 and the Claims(annual growth as % of broad money) in Turkey in 2008?
Your answer should be compact. 28.02. What is the difference between the Claims(annual growth as % of broad money) in Croatia in 2007 and the Claims(annual growth as % of broad money) in Qatar in 2008?
Provide a succinct answer. -31.36. What is the difference between the Claims(annual growth as % of broad money) in Croatia in 2007 and the Claims(annual growth as % of broad money) in Turkey in 2008?
Offer a terse response. -2.6. What is the difference between the Claims(annual growth as % of broad money) of Qatar in 2007 and the Claims(annual growth as % of broad money) of Turkey in 2008?
Keep it short and to the point. 35.68. What is the difference between the Claims(annual growth as % of broad money) in Bulgaria in 2007 and the Claims(annual growth as % of broad money) in Qatar in 2009?
Give a very brief answer. 42.66. What is the difference between the Claims(annual growth as % of broad money) in Bulgaria in 2007 and the Claims(annual growth as % of broad money) in Turkey in 2009?
Offer a very short reply. 36.13. What is the difference between the Claims(annual growth as % of broad money) of Croatia in 2007 and the Claims(annual growth as % of broad money) of Qatar in 2009?
Provide a succinct answer. 12.04. What is the difference between the Claims(annual growth as % of broad money) of Croatia in 2007 and the Claims(annual growth as % of broad money) of Turkey in 2009?
Make the answer very short. 5.52. What is the difference between the Claims(annual growth as % of broad money) of Qatar in 2007 and the Claims(annual growth as % of broad money) of Turkey in 2009?
Provide a succinct answer. 43.8. What is the difference between the Claims(annual growth as % of broad money) in Bulgaria in 2008 and the Claims(annual growth as % of broad money) in Qatar in 2009?
Keep it short and to the point. 25.67. What is the difference between the Claims(annual growth as % of broad money) of Bulgaria in 2008 and the Claims(annual growth as % of broad money) of Turkey in 2009?
Ensure brevity in your answer.  19.14. What is the difference between the Claims(annual growth as % of broad money) in Croatia in 2008 and the Claims(annual growth as % of broad money) in Qatar in 2009?
Give a very brief answer. 7.52. What is the difference between the Claims(annual growth as % of broad money) of Qatar in 2008 and the Claims(annual growth as % of broad money) of Turkey in 2009?
Keep it short and to the point. 36.88. What is the average Claims(annual growth as % of broad money) in Bulgaria per year?
Keep it short and to the point. 23.15. What is the average Claims(annual growth as % of broad money) in Croatia per year?
Provide a succinct answer. 13.62. What is the average Claims(annual growth as % of broad money) in Qatar per year?
Ensure brevity in your answer.  26.59. What is the average Claims(annual growth as % of broad money) in Turkey per year?
Offer a terse response. 17.19. In the year 2002, what is the difference between the Claims(annual growth as % of broad money) of Bulgaria and Claims(annual growth as % of broad money) of Croatia?
Your answer should be compact. -5.59. In the year 2002, what is the difference between the Claims(annual growth as % of broad money) of Bulgaria and Claims(annual growth as % of broad money) of Turkey?
Provide a succinct answer. -0.67. In the year 2002, what is the difference between the Claims(annual growth as % of broad money) in Croatia and Claims(annual growth as % of broad money) in Turkey?
Your answer should be compact. 4.92. In the year 2003, what is the difference between the Claims(annual growth as % of broad money) in Bulgaria and Claims(annual growth as % of broad money) in Croatia?
Provide a short and direct response. 10.32. In the year 2003, what is the difference between the Claims(annual growth as % of broad money) in Bulgaria and Claims(annual growth as % of broad money) in Qatar?
Make the answer very short. 8.16. In the year 2003, what is the difference between the Claims(annual growth as % of broad money) of Bulgaria and Claims(annual growth as % of broad money) of Turkey?
Give a very brief answer. 10.75. In the year 2003, what is the difference between the Claims(annual growth as % of broad money) in Croatia and Claims(annual growth as % of broad money) in Qatar?
Your answer should be compact. -2.15. In the year 2003, what is the difference between the Claims(annual growth as % of broad money) of Croatia and Claims(annual growth as % of broad money) of Turkey?
Offer a terse response. 0.43. In the year 2003, what is the difference between the Claims(annual growth as % of broad money) in Qatar and Claims(annual growth as % of broad money) in Turkey?
Your response must be concise. 2.58. In the year 2004, what is the difference between the Claims(annual growth as % of broad money) in Bulgaria and Claims(annual growth as % of broad money) in Croatia?
Provide a short and direct response. 15.49. In the year 2004, what is the difference between the Claims(annual growth as % of broad money) in Bulgaria and Claims(annual growth as % of broad money) in Qatar?
Your answer should be very brief. 8.88. In the year 2004, what is the difference between the Claims(annual growth as % of broad money) of Bulgaria and Claims(annual growth as % of broad money) of Turkey?
Provide a succinct answer. 9.29. In the year 2004, what is the difference between the Claims(annual growth as % of broad money) of Croatia and Claims(annual growth as % of broad money) of Qatar?
Offer a very short reply. -6.6. In the year 2004, what is the difference between the Claims(annual growth as % of broad money) of Croatia and Claims(annual growth as % of broad money) of Turkey?
Your response must be concise. -6.2. In the year 2004, what is the difference between the Claims(annual growth as % of broad money) of Qatar and Claims(annual growth as % of broad money) of Turkey?
Make the answer very short. 0.41. In the year 2005, what is the difference between the Claims(annual growth as % of broad money) in Bulgaria and Claims(annual growth as % of broad money) in Croatia?
Your answer should be compact. 6.78. In the year 2005, what is the difference between the Claims(annual growth as % of broad money) of Bulgaria and Claims(annual growth as % of broad money) of Qatar?
Give a very brief answer. -19.64. In the year 2005, what is the difference between the Claims(annual growth as % of broad money) of Bulgaria and Claims(annual growth as % of broad money) of Turkey?
Keep it short and to the point. -2.8. In the year 2005, what is the difference between the Claims(annual growth as % of broad money) of Croatia and Claims(annual growth as % of broad money) of Qatar?
Provide a succinct answer. -26.42. In the year 2005, what is the difference between the Claims(annual growth as % of broad money) of Croatia and Claims(annual growth as % of broad money) of Turkey?
Make the answer very short. -9.58. In the year 2005, what is the difference between the Claims(annual growth as % of broad money) in Qatar and Claims(annual growth as % of broad money) in Turkey?
Your response must be concise. 16.84. In the year 2006, what is the difference between the Claims(annual growth as % of broad money) of Bulgaria and Claims(annual growth as % of broad money) of Croatia?
Your answer should be very brief. -3.64. In the year 2006, what is the difference between the Claims(annual growth as % of broad money) in Bulgaria and Claims(annual growth as % of broad money) in Qatar?
Provide a succinct answer. -16.21. In the year 2006, what is the difference between the Claims(annual growth as % of broad money) of Bulgaria and Claims(annual growth as % of broad money) of Turkey?
Your answer should be very brief. -2.24. In the year 2006, what is the difference between the Claims(annual growth as % of broad money) in Croatia and Claims(annual growth as % of broad money) in Qatar?
Your response must be concise. -12.58. In the year 2006, what is the difference between the Claims(annual growth as % of broad money) of Croatia and Claims(annual growth as % of broad money) of Turkey?
Your response must be concise. 1.4. In the year 2006, what is the difference between the Claims(annual growth as % of broad money) of Qatar and Claims(annual growth as % of broad money) of Turkey?
Your answer should be very brief. 13.97. In the year 2007, what is the difference between the Claims(annual growth as % of broad money) of Bulgaria and Claims(annual growth as % of broad money) of Croatia?
Provide a succinct answer. 30.62. In the year 2007, what is the difference between the Claims(annual growth as % of broad money) in Bulgaria and Claims(annual growth as % of broad money) in Qatar?
Ensure brevity in your answer.  -7.67. In the year 2007, what is the difference between the Claims(annual growth as % of broad money) in Bulgaria and Claims(annual growth as % of broad money) in Turkey?
Provide a short and direct response. 27.7. In the year 2007, what is the difference between the Claims(annual growth as % of broad money) of Croatia and Claims(annual growth as % of broad money) of Qatar?
Ensure brevity in your answer.  -38.28. In the year 2007, what is the difference between the Claims(annual growth as % of broad money) of Croatia and Claims(annual growth as % of broad money) of Turkey?
Your response must be concise. -2.91. In the year 2007, what is the difference between the Claims(annual growth as % of broad money) of Qatar and Claims(annual growth as % of broad money) of Turkey?
Your answer should be compact. 35.37. In the year 2008, what is the difference between the Claims(annual growth as % of broad money) of Bulgaria and Claims(annual growth as % of broad money) of Croatia?
Give a very brief answer. 18.15. In the year 2008, what is the difference between the Claims(annual growth as % of broad money) of Bulgaria and Claims(annual growth as % of broad money) of Qatar?
Give a very brief answer. -17.74. In the year 2008, what is the difference between the Claims(annual growth as % of broad money) in Bulgaria and Claims(annual growth as % of broad money) in Turkey?
Your response must be concise. 11.03. In the year 2008, what is the difference between the Claims(annual growth as % of broad money) of Croatia and Claims(annual growth as % of broad money) of Qatar?
Offer a very short reply. -35.88. In the year 2008, what is the difference between the Claims(annual growth as % of broad money) of Croatia and Claims(annual growth as % of broad money) of Turkey?
Keep it short and to the point. -7.12. In the year 2008, what is the difference between the Claims(annual growth as % of broad money) in Qatar and Claims(annual growth as % of broad money) in Turkey?
Your answer should be very brief. 28.76. In the year 2009, what is the difference between the Claims(annual growth as % of broad money) in Bulgaria and Claims(annual growth as % of broad money) in Qatar?
Your answer should be very brief. 1.22. In the year 2009, what is the difference between the Claims(annual growth as % of broad money) of Bulgaria and Claims(annual growth as % of broad money) of Turkey?
Provide a succinct answer. -5.31. In the year 2009, what is the difference between the Claims(annual growth as % of broad money) of Qatar and Claims(annual growth as % of broad money) of Turkey?
Provide a short and direct response. -6.53. What is the ratio of the Claims(annual growth as % of broad money) of Bulgaria in 2002 to that in 2003?
Offer a terse response. 0.69. What is the ratio of the Claims(annual growth as % of broad money) in Croatia in 2002 to that in 2003?
Make the answer very short. 1.75. What is the ratio of the Claims(annual growth as % of broad money) in Turkey in 2002 to that in 2003?
Your answer should be very brief. 1.39. What is the ratio of the Claims(annual growth as % of broad money) in Bulgaria in 2002 to that in 2004?
Offer a terse response. 0.55. What is the ratio of the Claims(annual growth as % of broad money) of Croatia in 2002 to that in 2004?
Your answer should be compact. 1.65. What is the ratio of the Claims(annual growth as % of broad money) of Turkey in 2002 to that in 2004?
Your response must be concise. 0.85. What is the ratio of the Claims(annual growth as % of broad money) of Bulgaria in 2002 to that in 2005?
Offer a very short reply. 0.7. What is the ratio of the Claims(annual growth as % of broad money) in Croatia in 2002 to that in 2005?
Keep it short and to the point. 1.36. What is the ratio of the Claims(annual growth as % of broad money) of Turkey in 2002 to that in 2005?
Your answer should be compact. 0.65. What is the ratio of the Claims(annual growth as % of broad money) in Bulgaria in 2002 to that in 2006?
Give a very brief answer. 0.84. What is the ratio of the Claims(annual growth as % of broad money) of Croatia in 2002 to that in 2006?
Make the answer very short. 0.96. What is the ratio of the Claims(annual growth as % of broad money) of Turkey in 2002 to that in 2006?
Ensure brevity in your answer.  0.78. What is the ratio of the Claims(annual growth as % of broad money) of Bulgaria in 2002 to that in 2007?
Ensure brevity in your answer.  0.34. What is the ratio of the Claims(annual growth as % of broad money) in Croatia in 2002 to that in 2007?
Ensure brevity in your answer.  1.41. What is the ratio of the Claims(annual growth as % of broad money) of Turkey in 2002 to that in 2007?
Your response must be concise. 0.91. What is the ratio of the Claims(annual growth as % of broad money) in Bulgaria in 2002 to that in 2008?
Ensure brevity in your answer.  0.54. What is the ratio of the Claims(annual growth as % of broad money) of Croatia in 2002 to that in 2008?
Your answer should be very brief. 2.03. What is the ratio of the Claims(annual growth as % of broad money) in Turkey in 2002 to that in 2008?
Give a very brief answer. 0.92. What is the ratio of the Claims(annual growth as % of broad money) in Bulgaria in 2002 to that in 2009?
Your answer should be compact. 3.77. What is the ratio of the Claims(annual growth as % of broad money) in Turkey in 2002 to that in 2009?
Your response must be concise. 1.72. What is the ratio of the Claims(annual growth as % of broad money) in Bulgaria in 2003 to that in 2004?
Offer a terse response. 0.79. What is the ratio of the Claims(annual growth as % of broad money) of Croatia in 2003 to that in 2004?
Provide a succinct answer. 0.95. What is the ratio of the Claims(annual growth as % of broad money) in Qatar in 2003 to that in 2004?
Offer a very short reply. 0.73. What is the ratio of the Claims(annual growth as % of broad money) of Turkey in 2003 to that in 2004?
Provide a succinct answer. 0.61. What is the ratio of the Claims(annual growth as % of broad money) of Croatia in 2003 to that in 2005?
Provide a succinct answer. 0.78. What is the ratio of the Claims(annual growth as % of broad money) of Qatar in 2003 to that in 2005?
Ensure brevity in your answer.  0.34. What is the ratio of the Claims(annual growth as % of broad money) in Turkey in 2003 to that in 2005?
Your answer should be compact. 0.46. What is the ratio of the Claims(annual growth as % of broad money) of Bulgaria in 2003 to that in 2006?
Your answer should be compact. 1.21. What is the ratio of the Claims(annual growth as % of broad money) of Croatia in 2003 to that in 2006?
Provide a short and direct response. 0.55. What is the ratio of the Claims(annual growth as % of broad money) of Qatar in 2003 to that in 2006?
Give a very brief answer. 0.41. What is the ratio of the Claims(annual growth as % of broad money) of Turkey in 2003 to that in 2006?
Your answer should be very brief. 0.56. What is the ratio of the Claims(annual growth as % of broad money) in Bulgaria in 2003 to that in 2007?
Give a very brief answer. 0.49. What is the ratio of the Claims(annual growth as % of broad money) of Croatia in 2003 to that in 2007?
Keep it short and to the point. 0.81. What is the ratio of the Claims(annual growth as % of broad money) of Qatar in 2003 to that in 2007?
Keep it short and to the point. 0.27. What is the ratio of the Claims(annual growth as % of broad money) of Turkey in 2003 to that in 2007?
Offer a terse response. 0.65. What is the ratio of the Claims(annual growth as % of broad money) of Bulgaria in 2003 to that in 2008?
Offer a very short reply. 0.78. What is the ratio of the Claims(annual growth as % of broad money) of Croatia in 2003 to that in 2008?
Offer a very short reply. 1.16. What is the ratio of the Claims(annual growth as % of broad money) of Qatar in 2003 to that in 2008?
Your answer should be compact. 0.31. What is the ratio of the Claims(annual growth as % of broad money) of Turkey in 2003 to that in 2008?
Provide a succinct answer. 0.66. What is the ratio of the Claims(annual growth as % of broad money) in Bulgaria in 2003 to that in 2009?
Offer a very short reply. 5.44. What is the ratio of the Claims(annual growth as % of broad money) of Qatar in 2003 to that in 2009?
Offer a terse response. 4.91. What is the ratio of the Claims(annual growth as % of broad money) of Turkey in 2003 to that in 2009?
Offer a terse response. 1.24. What is the ratio of the Claims(annual growth as % of broad money) of Bulgaria in 2004 to that in 2005?
Ensure brevity in your answer.  1.27. What is the ratio of the Claims(annual growth as % of broad money) of Croatia in 2004 to that in 2005?
Your answer should be very brief. 0.82. What is the ratio of the Claims(annual growth as % of broad money) of Qatar in 2004 to that in 2005?
Offer a very short reply. 0.46. What is the ratio of the Claims(annual growth as % of broad money) of Turkey in 2004 to that in 2005?
Make the answer very short. 0.76. What is the ratio of the Claims(annual growth as % of broad money) in Bulgaria in 2004 to that in 2006?
Your answer should be very brief. 1.53. What is the ratio of the Claims(annual growth as % of broad money) in Croatia in 2004 to that in 2006?
Offer a terse response. 0.58. What is the ratio of the Claims(annual growth as % of broad money) in Qatar in 2004 to that in 2006?
Your response must be concise. 0.56. What is the ratio of the Claims(annual growth as % of broad money) in Turkey in 2004 to that in 2006?
Make the answer very short. 0.92. What is the ratio of the Claims(annual growth as % of broad money) of Bulgaria in 2004 to that in 2007?
Keep it short and to the point. 0.62. What is the ratio of the Claims(annual growth as % of broad money) in Croatia in 2004 to that in 2007?
Your answer should be very brief. 0.86. What is the ratio of the Claims(annual growth as % of broad money) of Qatar in 2004 to that in 2007?
Your response must be concise. 0.36. What is the ratio of the Claims(annual growth as % of broad money) in Turkey in 2004 to that in 2007?
Give a very brief answer. 1.06. What is the ratio of the Claims(annual growth as % of broad money) in Croatia in 2004 to that in 2008?
Your answer should be compact. 1.23. What is the ratio of the Claims(annual growth as % of broad money) of Qatar in 2004 to that in 2008?
Make the answer very short. 0.42. What is the ratio of the Claims(annual growth as % of broad money) of Turkey in 2004 to that in 2008?
Your answer should be compact. 1.08. What is the ratio of the Claims(annual growth as % of broad money) in Bulgaria in 2004 to that in 2009?
Ensure brevity in your answer.  6.86. What is the ratio of the Claims(annual growth as % of broad money) in Qatar in 2004 to that in 2009?
Your answer should be compact. 6.69. What is the ratio of the Claims(annual growth as % of broad money) in Turkey in 2004 to that in 2009?
Make the answer very short. 2.01. What is the ratio of the Claims(annual growth as % of broad money) in Bulgaria in 2005 to that in 2006?
Offer a terse response. 1.21. What is the ratio of the Claims(annual growth as % of broad money) of Croatia in 2005 to that in 2006?
Give a very brief answer. 0.7. What is the ratio of the Claims(annual growth as % of broad money) of Qatar in 2005 to that in 2006?
Offer a terse response. 1.21. What is the ratio of the Claims(annual growth as % of broad money) of Turkey in 2005 to that in 2006?
Ensure brevity in your answer.  1.21. What is the ratio of the Claims(annual growth as % of broad money) of Bulgaria in 2005 to that in 2007?
Offer a very short reply. 0.49. What is the ratio of the Claims(annual growth as % of broad money) in Croatia in 2005 to that in 2007?
Your answer should be very brief. 1.04. What is the ratio of the Claims(annual growth as % of broad money) of Qatar in 2005 to that in 2007?
Offer a very short reply. 0.79. What is the ratio of the Claims(annual growth as % of broad money) of Turkey in 2005 to that in 2007?
Your response must be concise. 1.41. What is the ratio of the Claims(annual growth as % of broad money) in Bulgaria in 2005 to that in 2008?
Keep it short and to the point. 0.78. What is the ratio of the Claims(annual growth as % of broad money) in Croatia in 2005 to that in 2008?
Keep it short and to the point. 1.49. What is the ratio of the Claims(annual growth as % of broad money) in Qatar in 2005 to that in 2008?
Your answer should be compact. 0.91. What is the ratio of the Claims(annual growth as % of broad money) of Turkey in 2005 to that in 2008?
Your answer should be compact. 1.43. What is the ratio of the Claims(annual growth as % of broad money) in Bulgaria in 2005 to that in 2009?
Keep it short and to the point. 5.42. What is the ratio of the Claims(annual growth as % of broad money) of Qatar in 2005 to that in 2009?
Keep it short and to the point. 14.47. What is the ratio of the Claims(annual growth as % of broad money) of Turkey in 2005 to that in 2009?
Provide a succinct answer. 2.66. What is the ratio of the Claims(annual growth as % of broad money) in Bulgaria in 2006 to that in 2007?
Your response must be concise. 0.41. What is the ratio of the Claims(annual growth as % of broad money) in Croatia in 2006 to that in 2007?
Give a very brief answer. 1.48. What is the ratio of the Claims(annual growth as % of broad money) of Qatar in 2006 to that in 2007?
Keep it short and to the point. 0.65. What is the ratio of the Claims(annual growth as % of broad money) of Turkey in 2006 to that in 2007?
Your answer should be very brief. 1.16. What is the ratio of the Claims(annual growth as % of broad money) of Bulgaria in 2006 to that in 2008?
Give a very brief answer. 0.65. What is the ratio of the Claims(annual growth as % of broad money) of Croatia in 2006 to that in 2008?
Make the answer very short. 2.12. What is the ratio of the Claims(annual growth as % of broad money) in Qatar in 2006 to that in 2008?
Your answer should be very brief. 0.75. What is the ratio of the Claims(annual growth as % of broad money) of Turkey in 2006 to that in 2008?
Give a very brief answer. 1.18. What is the ratio of the Claims(annual growth as % of broad money) in Bulgaria in 2006 to that in 2009?
Your answer should be very brief. 4.48. What is the ratio of the Claims(annual growth as % of broad money) in Qatar in 2006 to that in 2009?
Offer a very short reply. 11.95. What is the ratio of the Claims(annual growth as % of broad money) in Turkey in 2006 to that in 2009?
Offer a very short reply. 2.2. What is the ratio of the Claims(annual growth as % of broad money) in Bulgaria in 2007 to that in 2008?
Your answer should be very brief. 1.59. What is the ratio of the Claims(annual growth as % of broad money) in Croatia in 2007 to that in 2008?
Offer a very short reply. 1.43. What is the ratio of the Claims(annual growth as % of broad money) in Qatar in 2007 to that in 2008?
Your answer should be very brief. 1.15. What is the ratio of the Claims(annual growth as % of broad money) of Turkey in 2007 to that in 2008?
Provide a succinct answer. 1.02. What is the ratio of the Claims(annual growth as % of broad money) in Bulgaria in 2007 to that in 2009?
Your answer should be very brief. 11.06. What is the ratio of the Claims(annual growth as % of broad money) of Qatar in 2007 to that in 2009?
Provide a succinct answer. 18.35. What is the ratio of the Claims(annual growth as % of broad money) in Turkey in 2007 to that in 2009?
Your answer should be compact. 1.89. What is the ratio of the Claims(annual growth as % of broad money) of Bulgaria in 2008 to that in 2009?
Your answer should be compact. 6.94. What is the ratio of the Claims(annual growth as % of broad money) of Qatar in 2008 to that in 2009?
Your answer should be compact. 15.97. What is the ratio of the Claims(annual growth as % of broad money) of Turkey in 2008 to that in 2009?
Provide a short and direct response. 1.86. What is the difference between the highest and the second highest Claims(annual growth as % of broad money) in Bulgaria?
Ensure brevity in your answer.  16.99. What is the difference between the highest and the second highest Claims(annual growth as % of broad money) in Croatia?
Provide a short and direct response. 0.96. What is the difference between the highest and the second highest Claims(annual growth as % of broad money) of Qatar?
Provide a succinct answer. 6.92. What is the difference between the highest and the second highest Claims(annual growth as % of broad money) in Turkey?
Give a very brief answer. 4.42. What is the difference between the highest and the lowest Claims(annual growth as % of broad money) in Bulgaria?
Your answer should be compact. 41.44. What is the difference between the highest and the lowest Claims(annual growth as % of broad money) of Croatia?
Your answer should be very brief. 22.09. What is the difference between the highest and the lowest Claims(annual growth as % of broad money) of Qatar?
Keep it short and to the point. 53.22. What is the difference between the highest and the lowest Claims(annual growth as % of broad money) of Turkey?
Your response must be concise. 15.69. 